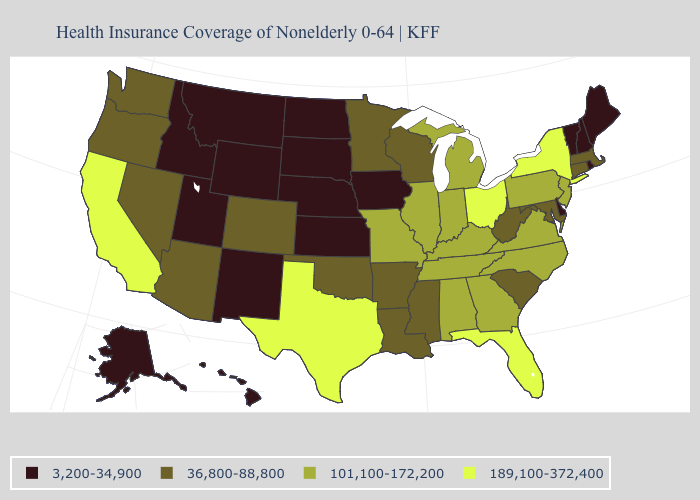Name the states that have a value in the range 36,800-88,800?
Concise answer only. Arizona, Arkansas, Colorado, Connecticut, Louisiana, Maryland, Massachusetts, Minnesota, Mississippi, Nevada, Oklahoma, Oregon, South Carolina, Washington, West Virginia, Wisconsin. Name the states that have a value in the range 3,200-34,900?
Short answer required. Alaska, Delaware, Hawaii, Idaho, Iowa, Kansas, Maine, Montana, Nebraska, New Hampshire, New Mexico, North Dakota, Rhode Island, South Dakota, Utah, Vermont, Wyoming. What is the highest value in the West ?
Quick response, please. 189,100-372,400. What is the value of Nevada?
Write a very short answer. 36,800-88,800. Among the states that border Nebraska , does Kansas have the lowest value?
Short answer required. Yes. What is the highest value in the USA?
Answer briefly. 189,100-372,400. What is the value of Kentucky?
Be succinct. 101,100-172,200. Which states have the lowest value in the USA?
Keep it brief. Alaska, Delaware, Hawaii, Idaho, Iowa, Kansas, Maine, Montana, Nebraska, New Hampshire, New Mexico, North Dakota, Rhode Island, South Dakota, Utah, Vermont, Wyoming. What is the value of Idaho?
Be succinct. 3,200-34,900. Does Rhode Island have the lowest value in the USA?
Concise answer only. Yes. What is the value of New Hampshire?
Be succinct. 3,200-34,900. What is the value of Arkansas?
Concise answer only. 36,800-88,800. Is the legend a continuous bar?
Concise answer only. No. What is the value of Virginia?
Short answer required. 101,100-172,200. Among the states that border Kentucky , which have the lowest value?
Keep it brief. West Virginia. 